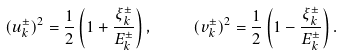<formula> <loc_0><loc_0><loc_500><loc_500>( u _ { k } ^ { \pm } ) ^ { 2 } = \frac { 1 } { 2 } \left ( 1 + \frac { \xi _ { k } ^ { \pm } } { E _ { k } ^ { \pm } } \right ) , \quad \ ( v _ { k } ^ { \pm } ) ^ { 2 } = \frac { 1 } { 2 } \left ( 1 - \frac { \xi _ { k } ^ { \pm } } { E _ { k } ^ { \pm } } \right ) .</formula> 